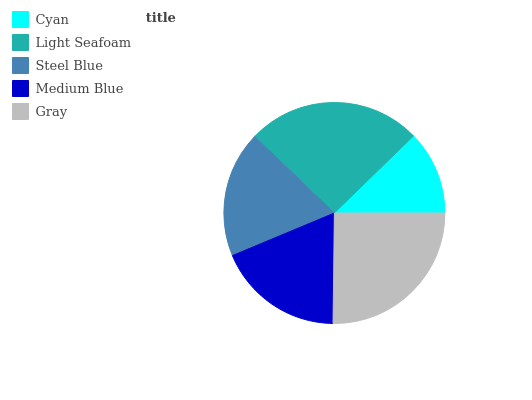Is Cyan the minimum?
Answer yes or no. Yes. Is Light Seafoam the maximum?
Answer yes or no. Yes. Is Steel Blue the minimum?
Answer yes or no. No. Is Steel Blue the maximum?
Answer yes or no. No. Is Light Seafoam greater than Steel Blue?
Answer yes or no. Yes. Is Steel Blue less than Light Seafoam?
Answer yes or no. Yes. Is Steel Blue greater than Light Seafoam?
Answer yes or no. No. Is Light Seafoam less than Steel Blue?
Answer yes or no. No. Is Medium Blue the high median?
Answer yes or no. Yes. Is Medium Blue the low median?
Answer yes or no. Yes. Is Steel Blue the high median?
Answer yes or no. No. Is Light Seafoam the low median?
Answer yes or no. No. 